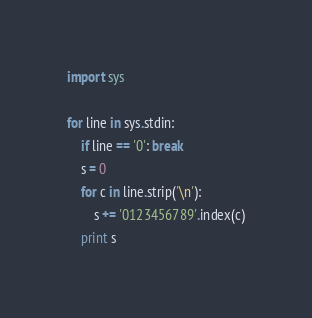<code> <loc_0><loc_0><loc_500><loc_500><_Python_>import sys

for line in sys.stdin:
    if line == '0': break
    s = 0
    for c in line.strip('\n'):
        s += '0123456789'.index(c)
    print s</code> 